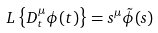Convert formula to latex. <formula><loc_0><loc_0><loc_500><loc_500>L \left \{ D _ { t } ^ { \mu } \phi ( t ) \right \} = s ^ { \mu } \tilde { \phi } ( s )</formula> 